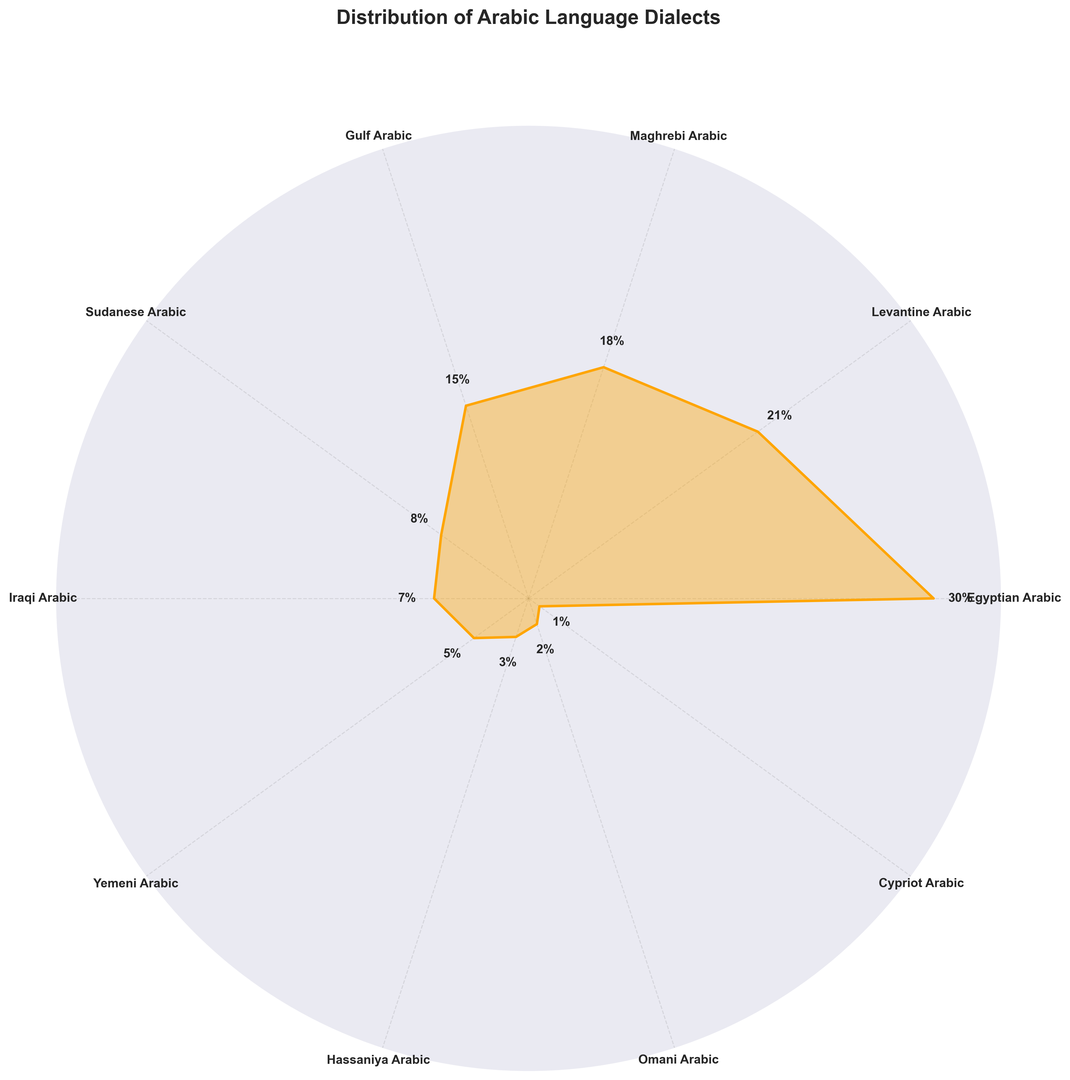What percentage of the chart is represented by Egyptian Arabic? By looking at the figure, we see that the segment labeled 'Egyptian Arabic' has the highest percentage label, which is 30%.
Answer: 30% Which dialects comprise more than 20% of the distribution? Observing the percentages around the chart, we see that only 'Egyptian Arabic' with 30% and 'Levantine Arabic' with 21% cross the 20% threshold.
Answer: Egyptian Arabic, Levantine Arabic What is the combined percentage of Iraqi Arabic and Yemeni Arabic? By locating the percentages for 'Iraqi Arabic' (7%) and 'Yemeni Arabic' (5%) and adding them together, we get 7% + 5% = 12%.
Answer: 12% Does Sudanese Arabic have a greater or lesser percentage than Maghrebi Arabic? Comparing the percentage values directly from the figure, 'Maghrebi Arabic' has 18%, while 'Sudanese Arabic' has 8%. Therefore, Sudanese Arabic has a lesser percentage.
Answer: Lesser Which dialect has the smallest representation, and what is its percentage? The smallest segment on the chart is labeled 'Cypriot Arabic,' and it has a percentage of 1%.
Answer: Cypriot Arabic, 1% How much greater is the percentage of Gulf Arabic compared to Hassaniya Arabic? Looking at the figure, 'Gulf Arabic' represents 15%, whereas 'Hassaniya Arabic' represents 3%. The difference is 15% - 3% = 12%.
Answer: 12% Rank the top three dialects by percentage. By examining the chart, we get 'Egyptian Arabic' (30%), 'Levantine Arabic' (21%), and 'Maghrebi Arabic' (18%). These are the top three dialects from largest to smallest.
Answer: Egyptian Arabic, Levantine Arabic, Maghrebi Arabic What is the average percentage of Sudanese Arabic, Iraqi Arabic, and Omani Arabic? The percentages are 'Sudanese Arabic' (8%), 'Iraqi Arabic' (7%), and 'Omani Arabic' (2%). Summing these gives 8% + 7% + 2% = 17%. Dividing by 3, the average is 17% / 3 ≈ 5.67%.
Answer: 5.67% What percentage do the Maghrebi Arabic and Gulf Arabic dialects combine to make? Maghrebi Arabic has 18%, and Gulf Arabic has 15%. Combining these, we get 18% + 15% = 33%.
Answer: 33% Which dialect is represented by the second-largest segment in the figure? The second-largest segment can be identified visually as the one labeled 'Levantine Arabic,' which stands at 21%.
Answer: Levantine Arabic 